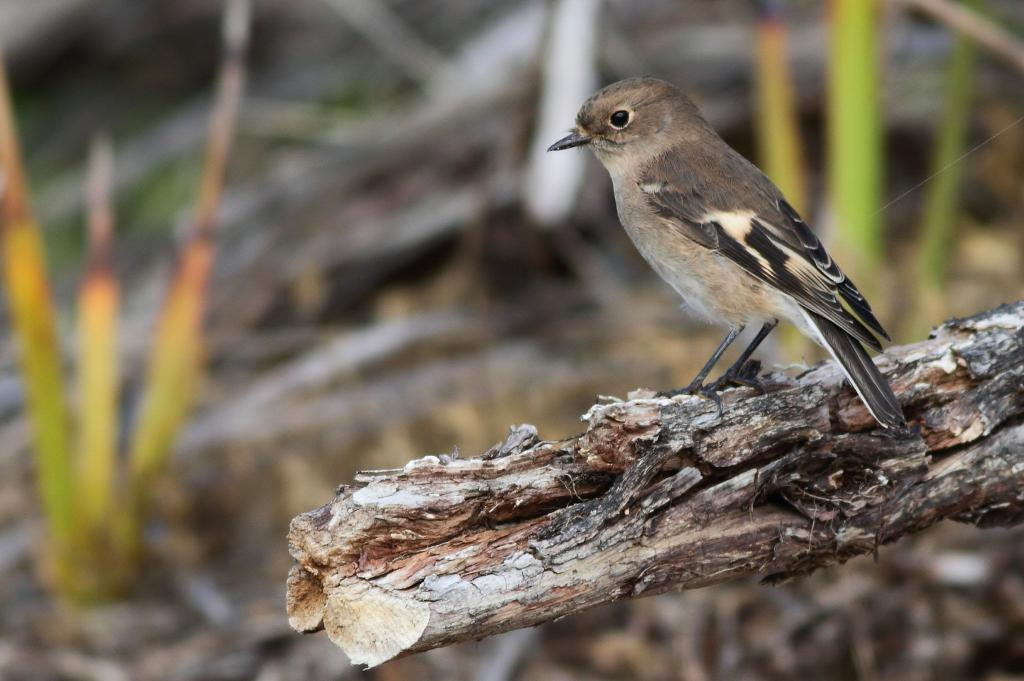What is located in the foreground of the image? There is a bird on wood in the foreground of the image. What can be seen in the background of the image? There are two plants in the background of the image. What is the bird's opinion on the current political climate in the image? There is no indication in the image that the bird has any opinion on the current political climate, as birds do not have the ability to express opinions. 